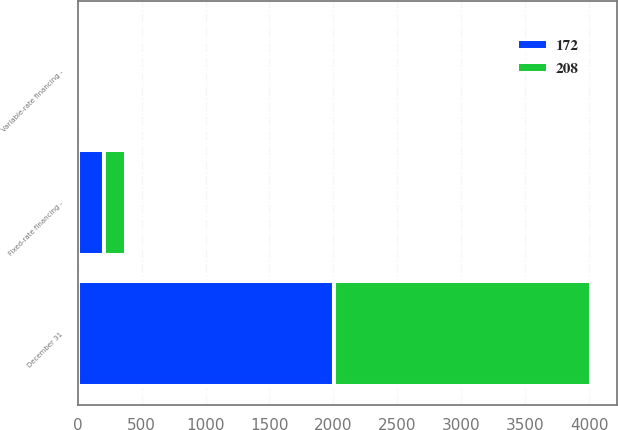Convert chart. <chart><loc_0><loc_0><loc_500><loc_500><stacked_bar_chart><ecel><fcel>December 31<fcel>Variable-rate financing -<fcel>Fixed-rate financing -<nl><fcel>172<fcel>2008<fcel>1<fcel>208<nl><fcel>208<fcel>2007<fcel>2<fcel>172<nl></chart> 